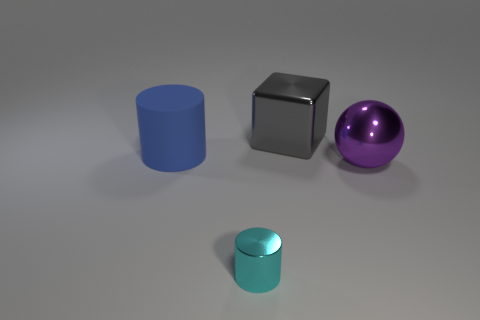Is there any other thing that is the same material as the large cylinder?
Provide a short and direct response. No. Are there any other things that are the same size as the cyan cylinder?
Your response must be concise. No. What size is the cylinder that is the same material as the purple object?
Give a very brief answer. Small. There is a cylinder that is made of the same material as the ball; what is its color?
Provide a succinct answer. Cyan. Is there a purple metal ball of the same size as the shiny block?
Offer a very short reply. Yes. There is another object that is the same shape as the matte thing; what is its material?
Your answer should be compact. Metal. There is a metal object that is the same size as the purple metallic sphere; what is its shape?
Keep it short and to the point. Cube. Is there a purple metallic object of the same shape as the small cyan metallic object?
Give a very brief answer. No. The metallic object that is to the right of the metallic object that is behind the rubber cylinder is what shape?
Your response must be concise. Sphere. The gray metal thing has what shape?
Provide a short and direct response. Cube. 